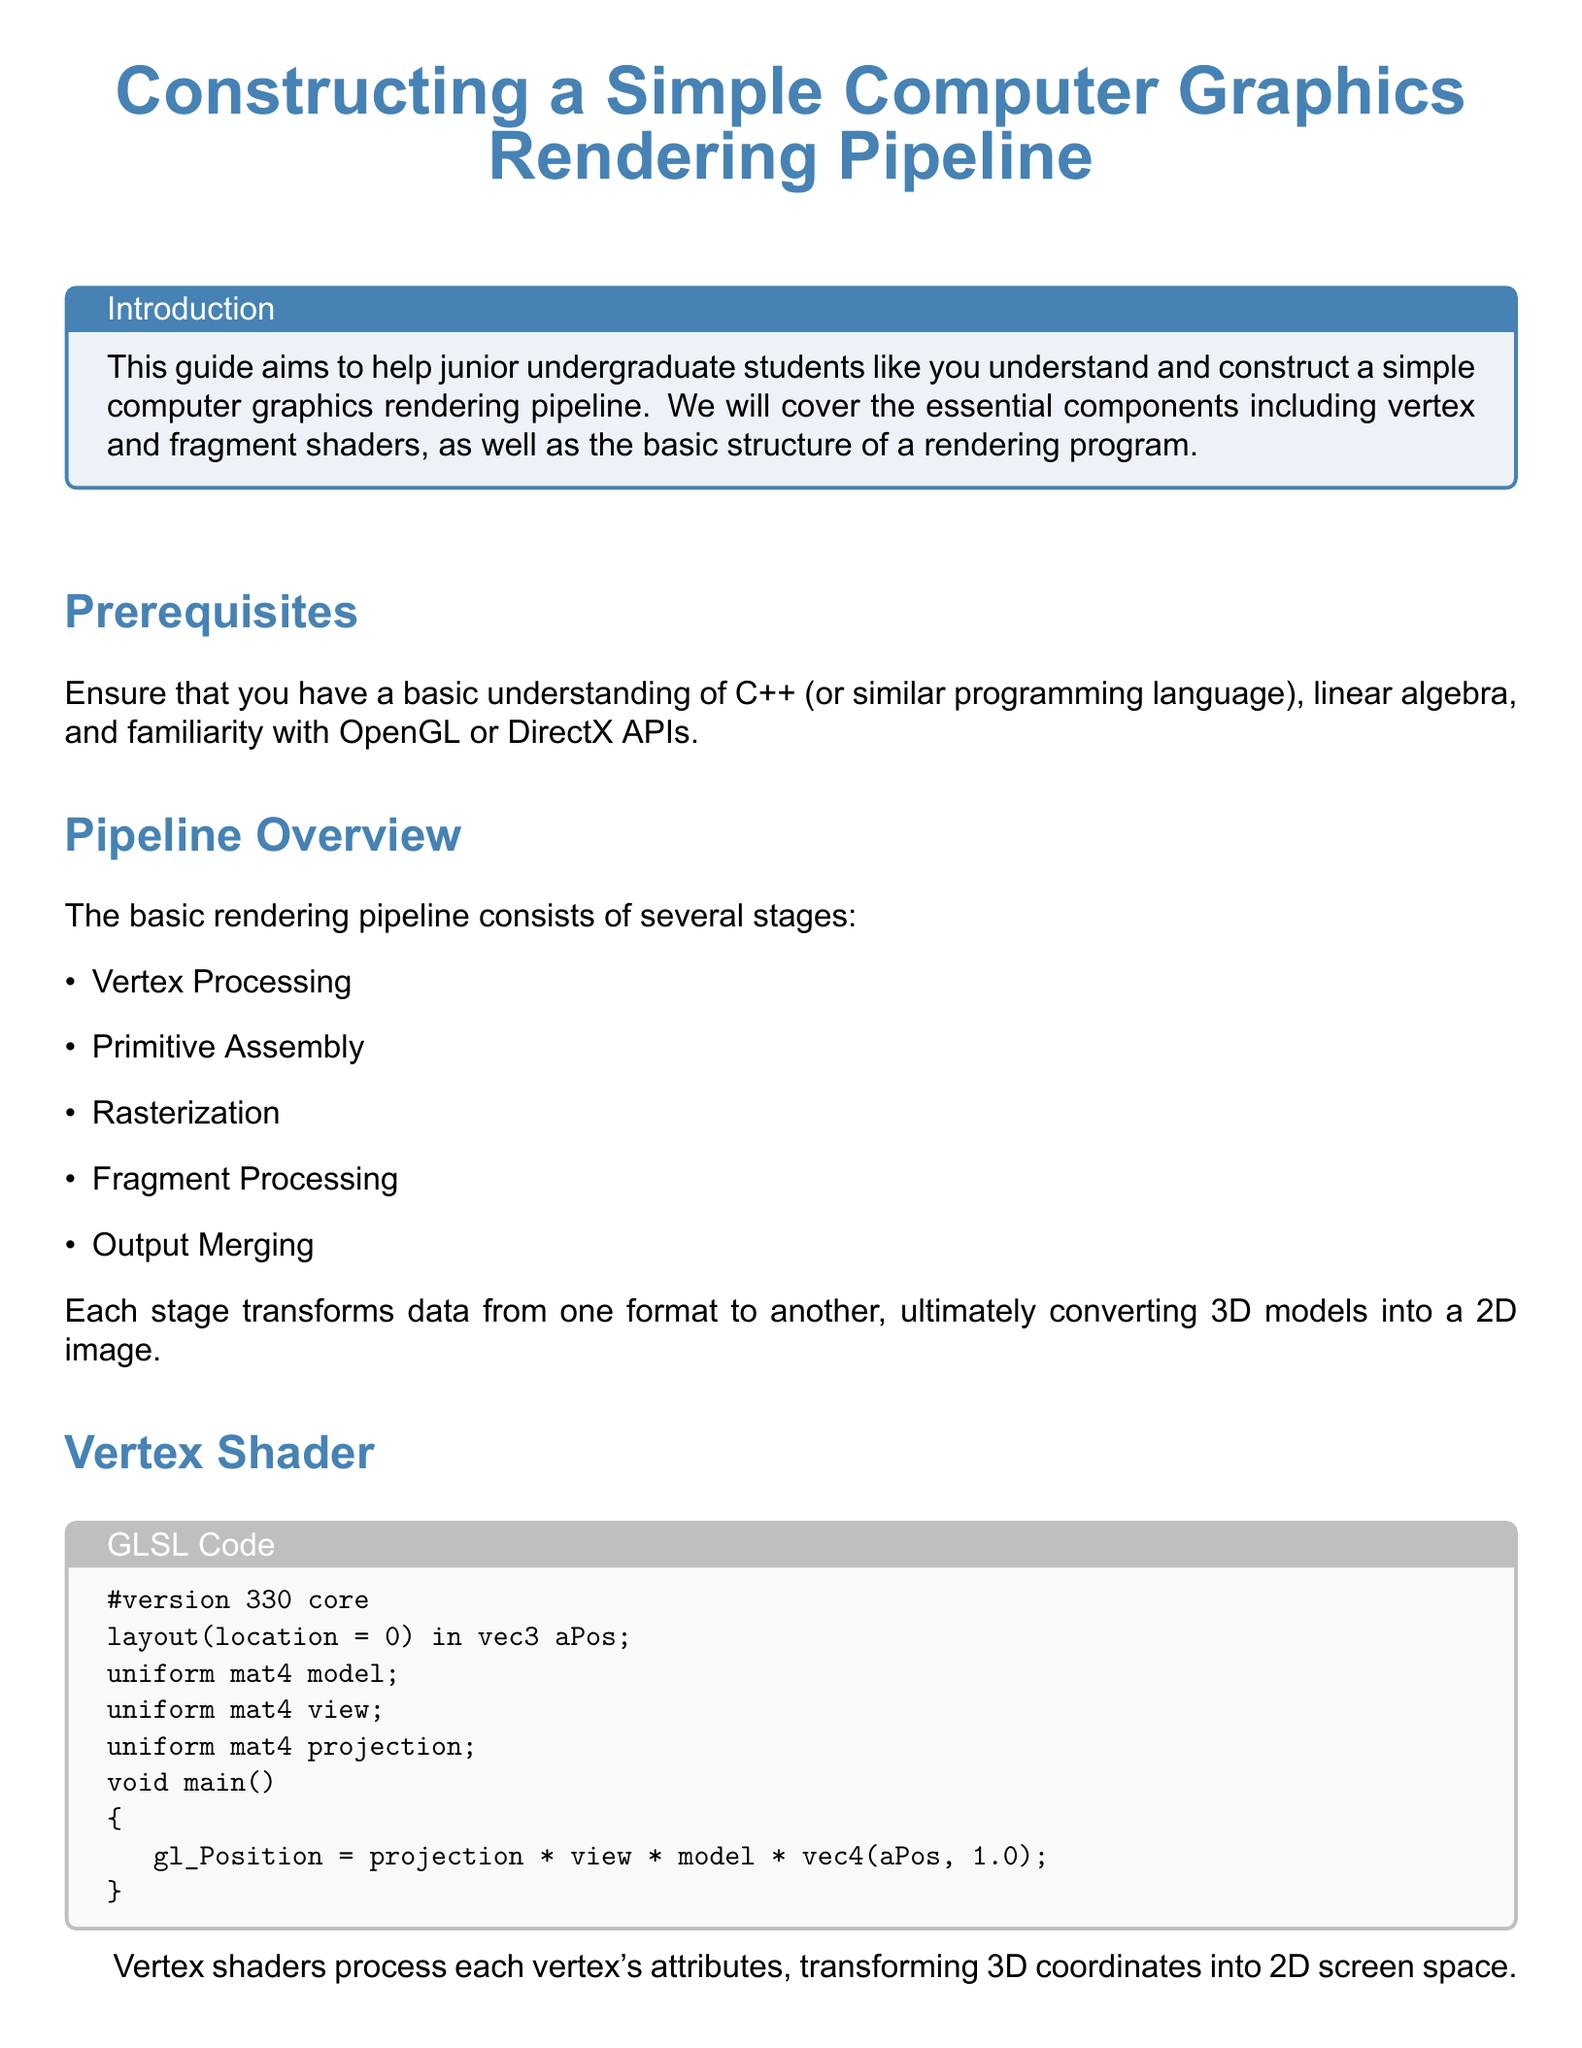What is the main color used in the title? The title is presented in the main color defined in the document which is specified as RGB(70,130,180).
Answer: maincolor What programming languages should you have a basic understanding of? The document mentions the need for a basic understanding of C++ or similar programming languages.
Answer: C++ How many stages are there in the basic rendering pipeline? It lists five stages in the pipeline overview section.
Answer: five What does the vertex shader output to the gl_Position? The vertex shader transforms the 3D coordinates into 2D screen space, outputting through gl_Position.
Answer: projection * view * model * vec4(aPos, 1.0) What color does the fragment shader set for FragColor? The fragment shader sets a specific color for FragColor as defined in the code.
Answer: vec4(1.0, 0.5, 0.2, 1.0) How many items are listed in the Setup Environment section? The setup environment section includes three steps.
Answer: three Which library header files are included in the C++ code sample? The code includes GL/glew.h and GLFW/glfw3.h to use the OpenGL and GLFW libraries.
Answer: GL/glew.h, GLFW/glfw3.h What is the purpose of glUseProgram in the rendering loop? The glUseProgram function is called to set the active shader program during rendering in the main loop.
Answer: set the active shader program What is the title of this document? The document title is prominently displayed at the beginning of the document.
Answer: Constructing a Simple Computer Graphics Rendering Pipeline 